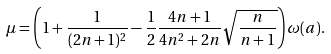Convert formula to latex. <formula><loc_0><loc_0><loc_500><loc_500>\mu = \left ( 1 + \frac { 1 } { ( 2 n + 1 ) ^ { 2 } } - \frac { 1 } { 2 } \frac { 4 n + 1 } { 4 n ^ { 2 } + 2 n } \sqrt { \frac { n } { n + 1 } } \right ) \omega ( a ) .</formula> 